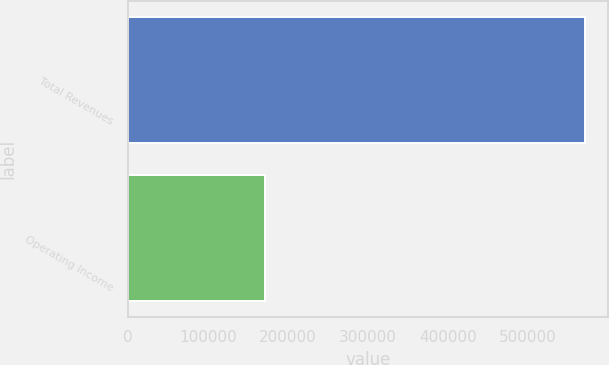Convert chart to OTSL. <chart><loc_0><loc_0><loc_500><loc_500><bar_chart><fcel>Total Revenues<fcel>Operating Income<nl><fcel>571263<fcel>170693<nl></chart> 